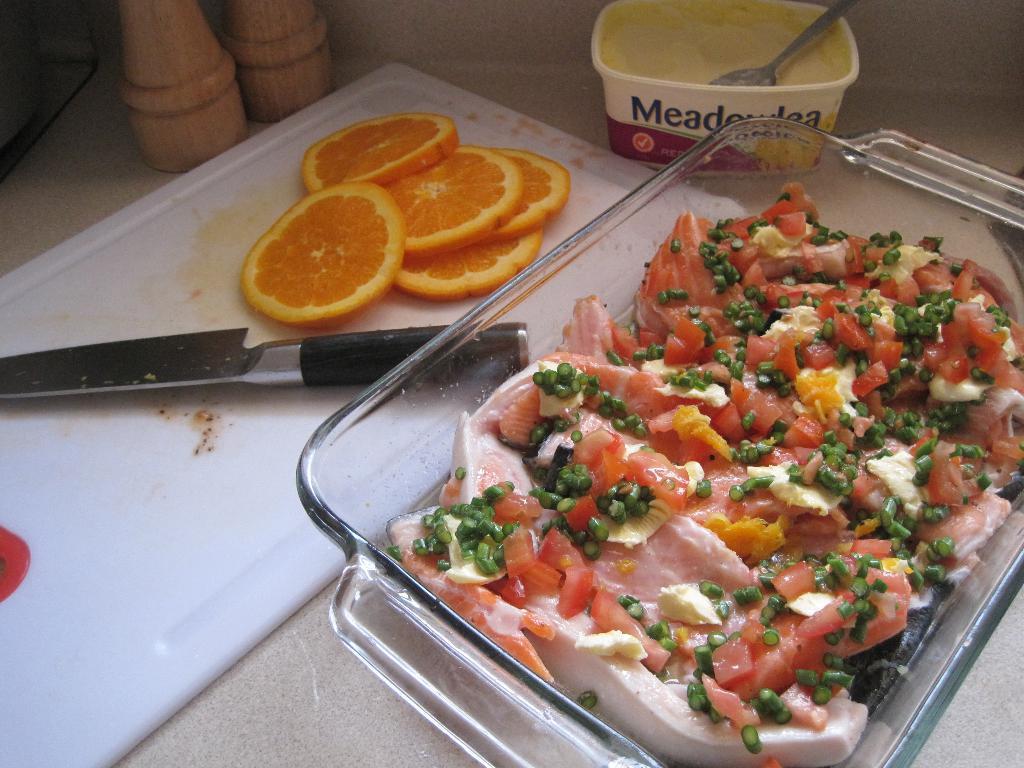How would you summarize this image in a sentence or two? In this picture I can see a food item in a glass tray, there are slices of lemon and a knife on the chopping board, there is a cream and a spoon in a box, there are salt and pepper grinders on the cabinet. 